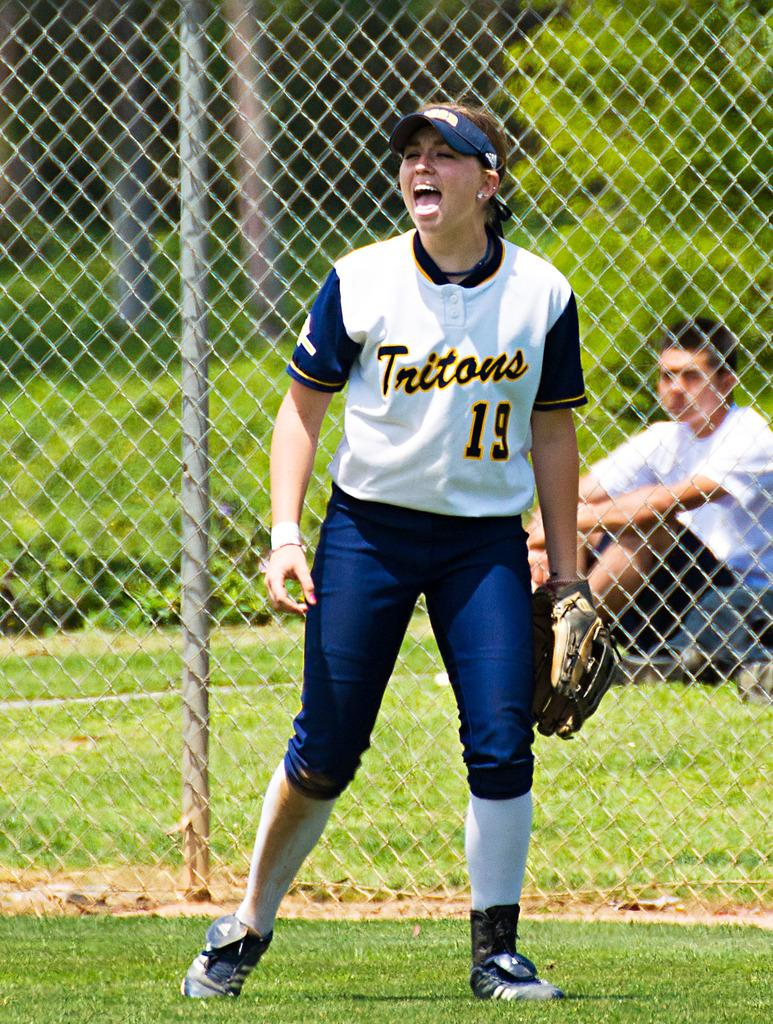<image>
Relay a brief, clear account of the picture shown. Player nineteen of the Tritons making a funny face. 